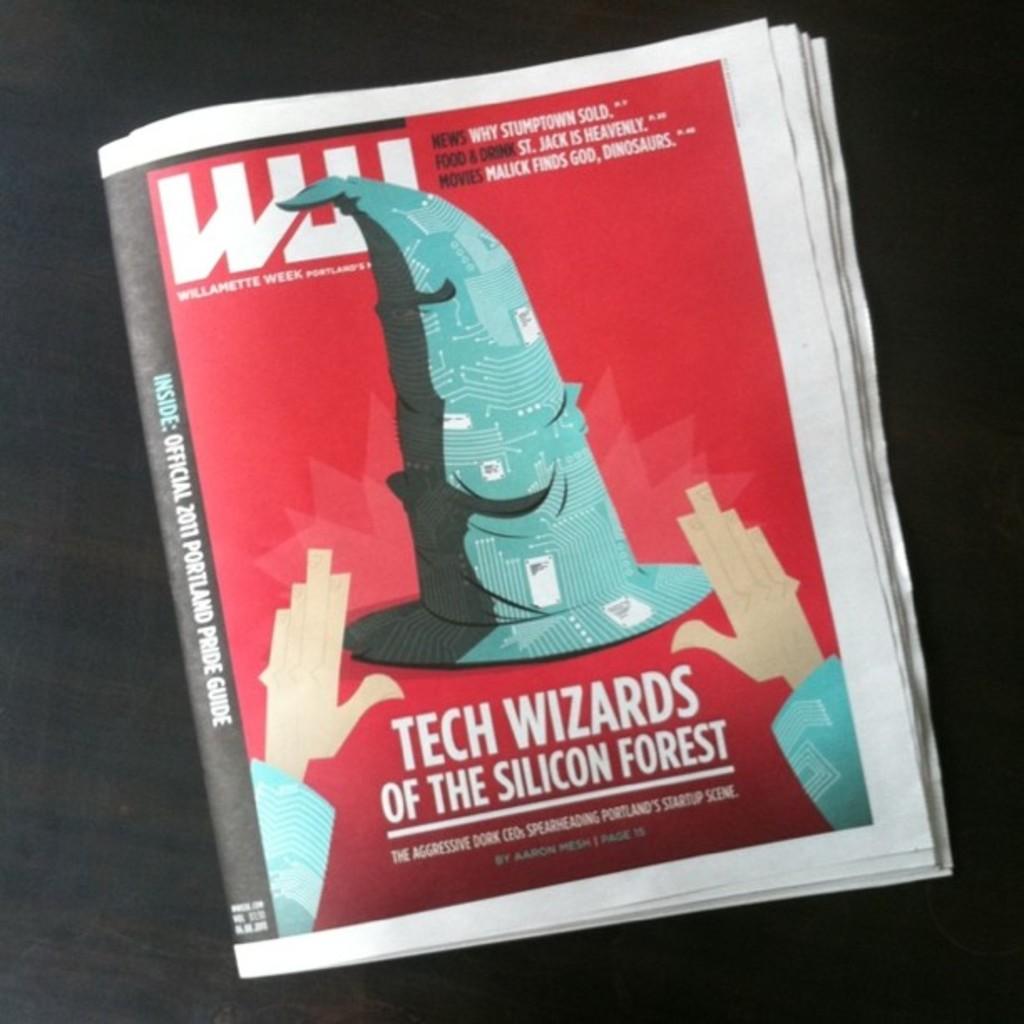Where are the tech wizards from?
Your response must be concise. Silicon forest. 